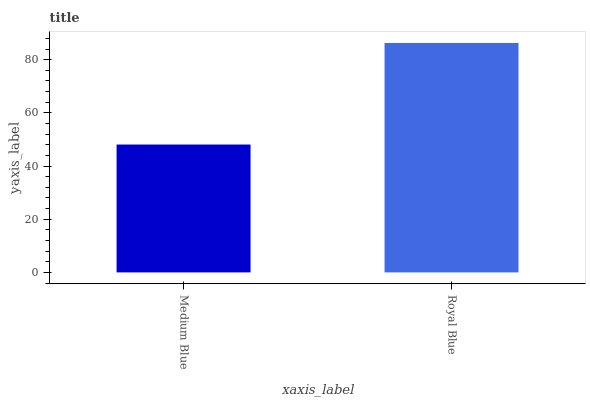Is Medium Blue the minimum?
Answer yes or no. Yes. Is Royal Blue the maximum?
Answer yes or no. Yes. Is Royal Blue the minimum?
Answer yes or no. No. Is Royal Blue greater than Medium Blue?
Answer yes or no. Yes. Is Medium Blue less than Royal Blue?
Answer yes or no. Yes. Is Medium Blue greater than Royal Blue?
Answer yes or no. No. Is Royal Blue less than Medium Blue?
Answer yes or no. No. Is Royal Blue the high median?
Answer yes or no. Yes. Is Medium Blue the low median?
Answer yes or no. Yes. Is Medium Blue the high median?
Answer yes or no. No. Is Royal Blue the low median?
Answer yes or no. No. 